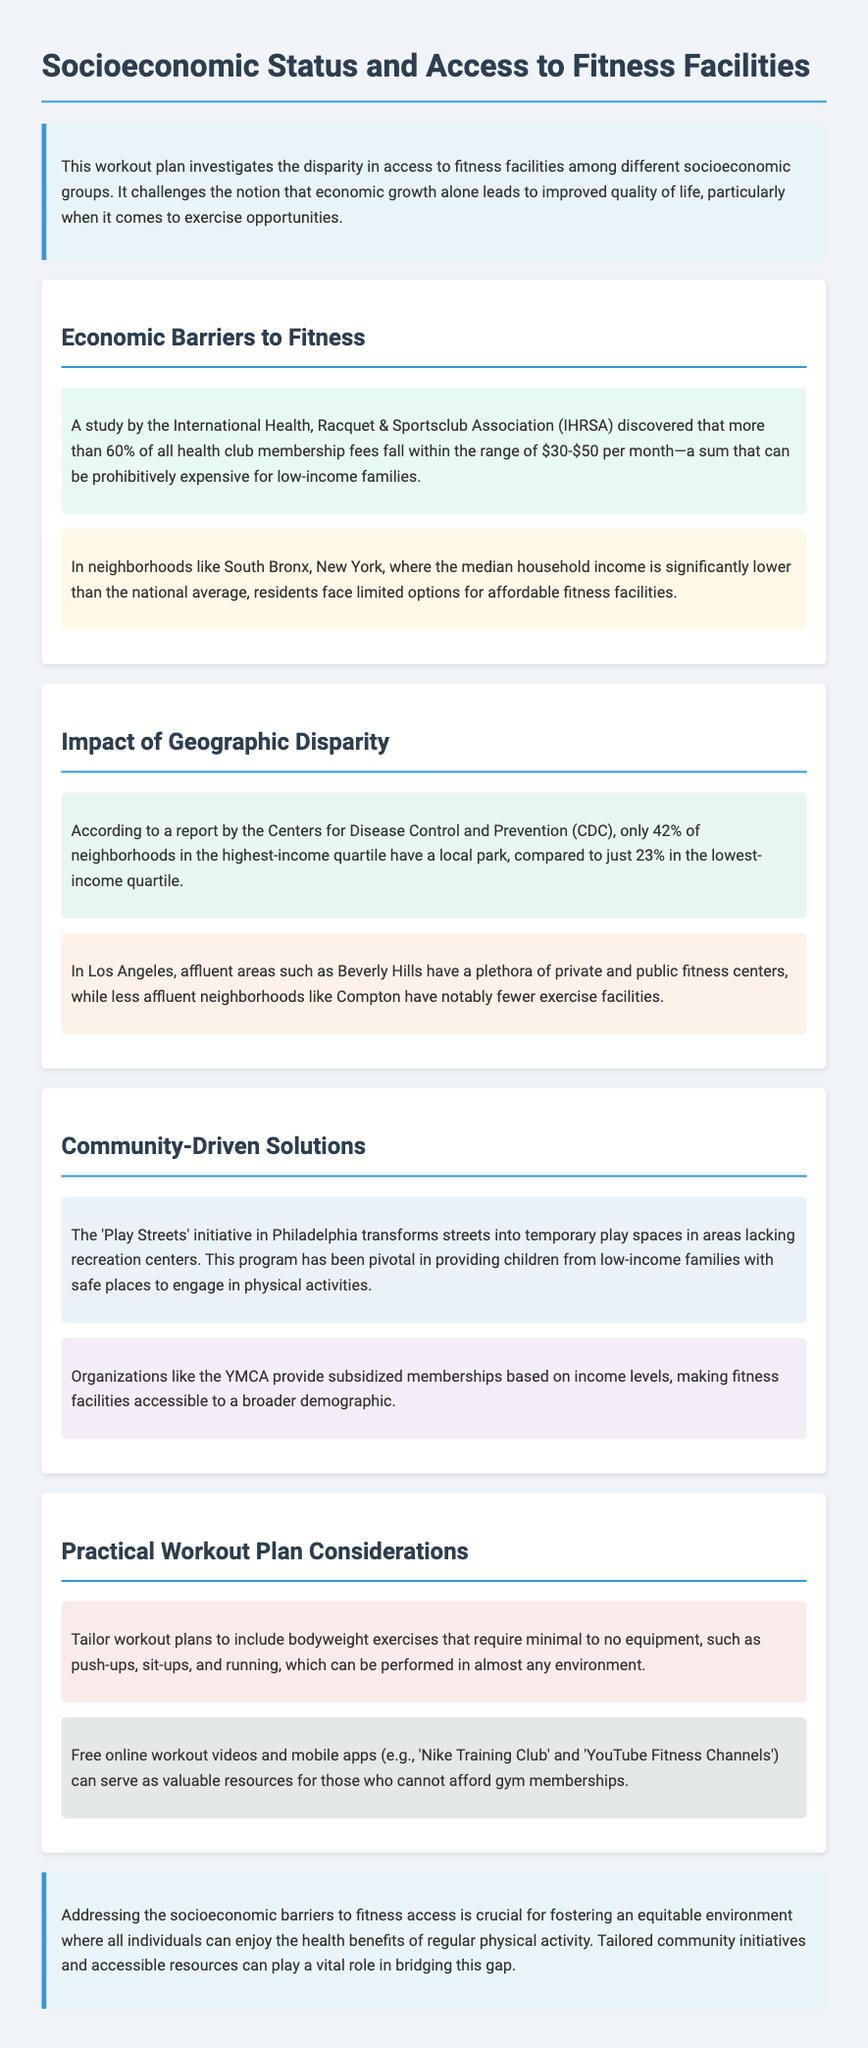What percentage of health club membership fees fall within the $30-$50 range? The document states that more than 60% of all health club membership fees fall within the $30-$50 per month range.
Answer: more than 60% What is the median household income status in South Bronx? The document indicates that the median household income in South Bronx is significantly lower than the national average.
Answer: significantly lower What percentage of neighborhoods in the highest-income quartile have a local park? According to the document, only 42% of neighborhoods in the highest-income quartile have a local park.
Answer: 42% Which area in Los Angeles has a plethora of fitness centers? The document mentions that affluent areas such as Beverly Hills have a plethora of private and public fitness centers.
Answer: Beverly Hills What initiative in Philadelphia creates temporary play spaces? The document refers to the 'Play Streets' initiative in Philadelphia as the program that transforms streets into temporary play spaces.
Answer: Play Streets What type of exercises are recommended for a workout plan? The document suggests including bodyweight exercises that require minimal to no equipment in the workout plan.
Answer: bodyweight exercises What organization provides subsidized memberships based on income levels? The document states that organizations like the YMCA provide subsidized memberships based on income levels.
Answer: YMCA What mobile app is mentioned as a resource for workouts? The document mentions 'Nike Training Club' as a mobile app serving as a valuable resource.
Answer: Nike Training Club 